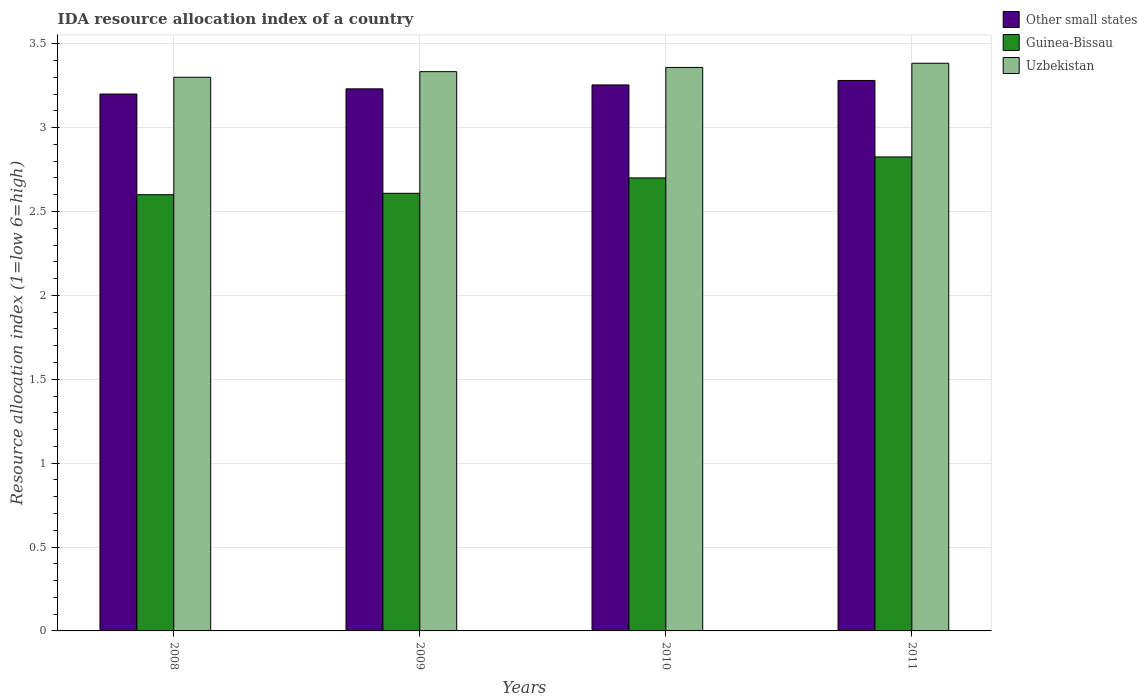Are the number of bars per tick equal to the number of legend labels?
Offer a terse response. Yes. Are the number of bars on each tick of the X-axis equal?
Your response must be concise. Yes. How many bars are there on the 4th tick from the left?
Provide a short and direct response. 3. How many bars are there on the 2nd tick from the right?
Offer a very short reply. 3. What is the label of the 3rd group of bars from the left?
Offer a very short reply. 2010. What is the IDA resource allocation index in Guinea-Bissau in 2010?
Your answer should be compact. 2.7. Across all years, what is the maximum IDA resource allocation index in Other small states?
Your answer should be compact. 3.28. In which year was the IDA resource allocation index in Uzbekistan minimum?
Offer a terse response. 2008. What is the total IDA resource allocation index in Guinea-Bissau in the graph?
Offer a terse response. 10.73. What is the difference between the IDA resource allocation index in Uzbekistan in 2010 and that in 2011?
Ensure brevity in your answer.  -0.03. What is the difference between the IDA resource allocation index in Uzbekistan in 2011 and the IDA resource allocation index in Other small states in 2009?
Make the answer very short. 0.15. What is the average IDA resource allocation index in Guinea-Bissau per year?
Provide a short and direct response. 2.68. In the year 2010, what is the difference between the IDA resource allocation index in Guinea-Bissau and IDA resource allocation index in Uzbekistan?
Provide a succinct answer. -0.66. In how many years, is the IDA resource allocation index in Uzbekistan greater than 0.2?
Keep it short and to the point. 4. What is the ratio of the IDA resource allocation index in Uzbekistan in 2010 to that in 2011?
Offer a terse response. 0.99. Is the IDA resource allocation index in Other small states in 2009 less than that in 2011?
Offer a very short reply. Yes. Is the difference between the IDA resource allocation index in Guinea-Bissau in 2009 and 2011 greater than the difference between the IDA resource allocation index in Uzbekistan in 2009 and 2011?
Your answer should be very brief. No. What is the difference between the highest and the second highest IDA resource allocation index in Other small states?
Ensure brevity in your answer.  0.03. What is the difference between the highest and the lowest IDA resource allocation index in Uzbekistan?
Your answer should be very brief. 0.08. In how many years, is the IDA resource allocation index in Guinea-Bissau greater than the average IDA resource allocation index in Guinea-Bissau taken over all years?
Make the answer very short. 2. Is the sum of the IDA resource allocation index in Guinea-Bissau in 2008 and 2009 greater than the maximum IDA resource allocation index in Other small states across all years?
Provide a short and direct response. Yes. What does the 1st bar from the left in 2011 represents?
Ensure brevity in your answer.  Other small states. What does the 3rd bar from the right in 2008 represents?
Make the answer very short. Other small states. How many bars are there?
Your answer should be compact. 12. How many years are there in the graph?
Your response must be concise. 4. What is the difference between two consecutive major ticks on the Y-axis?
Your answer should be compact. 0.5. Does the graph contain grids?
Offer a very short reply. Yes. How many legend labels are there?
Give a very brief answer. 3. How are the legend labels stacked?
Provide a short and direct response. Vertical. What is the title of the graph?
Offer a terse response. IDA resource allocation index of a country. What is the label or title of the X-axis?
Offer a terse response. Years. What is the label or title of the Y-axis?
Provide a short and direct response. Resource allocation index (1=low 6=high). What is the Resource allocation index (1=low 6=high) of Guinea-Bissau in 2008?
Make the answer very short. 2.6. What is the Resource allocation index (1=low 6=high) of Uzbekistan in 2008?
Your answer should be compact. 3.3. What is the Resource allocation index (1=low 6=high) of Other small states in 2009?
Ensure brevity in your answer.  3.23. What is the Resource allocation index (1=low 6=high) in Guinea-Bissau in 2009?
Your answer should be compact. 2.61. What is the Resource allocation index (1=low 6=high) in Uzbekistan in 2009?
Offer a terse response. 3.33. What is the Resource allocation index (1=low 6=high) in Other small states in 2010?
Your answer should be very brief. 3.25. What is the Resource allocation index (1=low 6=high) in Guinea-Bissau in 2010?
Your response must be concise. 2.7. What is the Resource allocation index (1=low 6=high) in Uzbekistan in 2010?
Keep it short and to the point. 3.36. What is the Resource allocation index (1=low 6=high) of Other small states in 2011?
Provide a succinct answer. 3.28. What is the Resource allocation index (1=low 6=high) in Guinea-Bissau in 2011?
Provide a succinct answer. 2.83. What is the Resource allocation index (1=low 6=high) in Uzbekistan in 2011?
Your answer should be very brief. 3.38. Across all years, what is the maximum Resource allocation index (1=low 6=high) in Other small states?
Offer a very short reply. 3.28. Across all years, what is the maximum Resource allocation index (1=low 6=high) of Guinea-Bissau?
Your answer should be very brief. 2.83. Across all years, what is the maximum Resource allocation index (1=low 6=high) in Uzbekistan?
Your answer should be very brief. 3.38. Across all years, what is the minimum Resource allocation index (1=low 6=high) in Guinea-Bissau?
Offer a very short reply. 2.6. Across all years, what is the minimum Resource allocation index (1=low 6=high) in Uzbekistan?
Provide a succinct answer. 3.3. What is the total Resource allocation index (1=low 6=high) of Other small states in the graph?
Keep it short and to the point. 12.97. What is the total Resource allocation index (1=low 6=high) of Guinea-Bissau in the graph?
Provide a succinct answer. 10.73. What is the total Resource allocation index (1=low 6=high) of Uzbekistan in the graph?
Your response must be concise. 13.38. What is the difference between the Resource allocation index (1=low 6=high) in Other small states in 2008 and that in 2009?
Your response must be concise. -0.03. What is the difference between the Resource allocation index (1=low 6=high) of Guinea-Bissau in 2008 and that in 2009?
Your answer should be compact. -0.01. What is the difference between the Resource allocation index (1=low 6=high) in Uzbekistan in 2008 and that in 2009?
Provide a short and direct response. -0.03. What is the difference between the Resource allocation index (1=low 6=high) in Other small states in 2008 and that in 2010?
Your answer should be compact. -0.05. What is the difference between the Resource allocation index (1=low 6=high) of Uzbekistan in 2008 and that in 2010?
Offer a terse response. -0.06. What is the difference between the Resource allocation index (1=low 6=high) in Other small states in 2008 and that in 2011?
Ensure brevity in your answer.  -0.08. What is the difference between the Resource allocation index (1=low 6=high) of Guinea-Bissau in 2008 and that in 2011?
Your answer should be very brief. -0.23. What is the difference between the Resource allocation index (1=low 6=high) in Uzbekistan in 2008 and that in 2011?
Your answer should be very brief. -0.08. What is the difference between the Resource allocation index (1=low 6=high) of Other small states in 2009 and that in 2010?
Your answer should be very brief. -0.02. What is the difference between the Resource allocation index (1=low 6=high) in Guinea-Bissau in 2009 and that in 2010?
Your answer should be compact. -0.09. What is the difference between the Resource allocation index (1=low 6=high) of Uzbekistan in 2009 and that in 2010?
Offer a terse response. -0.03. What is the difference between the Resource allocation index (1=low 6=high) of Guinea-Bissau in 2009 and that in 2011?
Provide a succinct answer. -0.22. What is the difference between the Resource allocation index (1=low 6=high) of Uzbekistan in 2009 and that in 2011?
Provide a succinct answer. -0.05. What is the difference between the Resource allocation index (1=low 6=high) of Other small states in 2010 and that in 2011?
Offer a very short reply. -0.03. What is the difference between the Resource allocation index (1=low 6=high) in Guinea-Bissau in 2010 and that in 2011?
Give a very brief answer. -0.12. What is the difference between the Resource allocation index (1=low 6=high) of Uzbekistan in 2010 and that in 2011?
Offer a terse response. -0.03. What is the difference between the Resource allocation index (1=low 6=high) of Other small states in 2008 and the Resource allocation index (1=low 6=high) of Guinea-Bissau in 2009?
Ensure brevity in your answer.  0.59. What is the difference between the Resource allocation index (1=low 6=high) in Other small states in 2008 and the Resource allocation index (1=low 6=high) in Uzbekistan in 2009?
Make the answer very short. -0.13. What is the difference between the Resource allocation index (1=low 6=high) of Guinea-Bissau in 2008 and the Resource allocation index (1=low 6=high) of Uzbekistan in 2009?
Make the answer very short. -0.73. What is the difference between the Resource allocation index (1=low 6=high) of Other small states in 2008 and the Resource allocation index (1=low 6=high) of Uzbekistan in 2010?
Give a very brief answer. -0.16. What is the difference between the Resource allocation index (1=low 6=high) of Guinea-Bissau in 2008 and the Resource allocation index (1=low 6=high) of Uzbekistan in 2010?
Give a very brief answer. -0.76. What is the difference between the Resource allocation index (1=low 6=high) in Other small states in 2008 and the Resource allocation index (1=low 6=high) in Guinea-Bissau in 2011?
Your response must be concise. 0.38. What is the difference between the Resource allocation index (1=low 6=high) in Other small states in 2008 and the Resource allocation index (1=low 6=high) in Uzbekistan in 2011?
Give a very brief answer. -0.18. What is the difference between the Resource allocation index (1=low 6=high) in Guinea-Bissau in 2008 and the Resource allocation index (1=low 6=high) in Uzbekistan in 2011?
Your answer should be compact. -0.78. What is the difference between the Resource allocation index (1=low 6=high) in Other small states in 2009 and the Resource allocation index (1=low 6=high) in Guinea-Bissau in 2010?
Make the answer very short. 0.53. What is the difference between the Resource allocation index (1=low 6=high) in Other small states in 2009 and the Resource allocation index (1=low 6=high) in Uzbekistan in 2010?
Make the answer very short. -0.13. What is the difference between the Resource allocation index (1=low 6=high) in Guinea-Bissau in 2009 and the Resource allocation index (1=low 6=high) in Uzbekistan in 2010?
Provide a succinct answer. -0.75. What is the difference between the Resource allocation index (1=low 6=high) in Other small states in 2009 and the Resource allocation index (1=low 6=high) in Guinea-Bissau in 2011?
Offer a terse response. 0.41. What is the difference between the Resource allocation index (1=low 6=high) in Other small states in 2009 and the Resource allocation index (1=low 6=high) in Uzbekistan in 2011?
Give a very brief answer. -0.15. What is the difference between the Resource allocation index (1=low 6=high) of Guinea-Bissau in 2009 and the Resource allocation index (1=low 6=high) of Uzbekistan in 2011?
Provide a short and direct response. -0.78. What is the difference between the Resource allocation index (1=low 6=high) in Other small states in 2010 and the Resource allocation index (1=low 6=high) in Guinea-Bissau in 2011?
Provide a succinct answer. 0.43. What is the difference between the Resource allocation index (1=low 6=high) in Other small states in 2010 and the Resource allocation index (1=low 6=high) in Uzbekistan in 2011?
Provide a succinct answer. -0.13. What is the difference between the Resource allocation index (1=low 6=high) of Guinea-Bissau in 2010 and the Resource allocation index (1=low 6=high) of Uzbekistan in 2011?
Offer a terse response. -0.68. What is the average Resource allocation index (1=low 6=high) of Other small states per year?
Give a very brief answer. 3.24. What is the average Resource allocation index (1=low 6=high) in Guinea-Bissau per year?
Offer a terse response. 2.68. What is the average Resource allocation index (1=low 6=high) in Uzbekistan per year?
Your response must be concise. 3.34. In the year 2008, what is the difference between the Resource allocation index (1=low 6=high) of Other small states and Resource allocation index (1=low 6=high) of Uzbekistan?
Give a very brief answer. -0.1. In the year 2009, what is the difference between the Resource allocation index (1=low 6=high) in Other small states and Resource allocation index (1=low 6=high) in Guinea-Bissau?
Keep it short and to the point. 0.62. In the year 2009, what is the difference between the Resource allocation index (1=low 6=high) in Other small states and Resource allocation index (1=low 6=high) in Uzbekistan?
Provide a succinct answer. -0.1. In the year 2009, what is the difference between the Resource allocation index (1=low 6=high) in Guinea-Bissau and Resource allocation index (1=low 6=high) in Uzbekistan?
Offer a terse response. -0.72. In the year 2010, what is the difference between the Resource allocation index (1=low 6=high) in Other small states and Resource allocation index (1=low 6=high) in Guinea-Bissau?
Your answer should be very brief. 0.55. In the year 2010, what is the difference between the Resource allocation index (1=low 6=high) of Other small states and Resource allocation index (1=low 6=high) of Uzbekistan?
Make the answer very short. -0.1. In the year 2010, what is the difference between the Resource allocation index (1=low 6=high) of Guinea-Bissau and Resource allocation index (1=low 6=high) of Uzbekistan?
Provide a succinct answer. -0.66. In the year 2011, what is the difference between the Resource allocation index (1=low 6=high) in Other small states and Resource allocation index (1=low 6=high) in Guinea-Bissau?
Your response must be concise. 0.46. In the year 2011, what is the difference between the Resource allocation index (1=low 6=high) of Other small states and Resource allocation index (1=low 6=high) of Uzbekistan?
Your response must be concise. -0.1. In the year 2011, what is the difference between the Resource allocation index (1=low 6=high) in Guinea-Bissau and Resource allocation index (1=low 6=high) in Uzbekistan?
Ensure brevity in your answer.  -0.56. What is the ratio of the Resource allocation index (1=low 6=high) in Guinea-Bissau in 2008 to that in 2009?
Your response must be concise. 1. What is the ratio of the Resource allocation index (1=low 6=high) in Uzbekistan in 2008 to that in 2009?
Your answer should be very brief. 0.99. What is the ratio of the Resource allocation index (1=low 6=high) of Other small states in 2008 to that in 2010?
Your answer should be compact. 0.98. What is the ratio of the Resource allocation index (1=low 6=high) of Guinea-Bissau in 2008 to that in 2010?
Provide a short and direct response. 0.96. What is the ratio of the Resource allocation index (1=low 6=high) in Uzbekistan in 2008 to that in 2010?
Offer a very short reply. 0.98. What is the ratio of the Resource allocation index (1=low 6=high) of Other small states in 2008 to that in 2011?
Keep it short and to the point. 0.98. What is the ratio of the Resource allocation index (1=low 6=high) of Guinea-Bissau in 2008 to that in 2011?
Provide a short and direct response. 0.92. What is the ratio of the Resource allocation index (1=low 6=high) in Uzbekistan in 2008 to that in 2011?
Your answer should be very brief. 0.98. What is the ratio of the Resource allocation index (1=low 6=high) in Other small states in 2009 to that in 2011?
Keep it short and to the point. 0.98. What is the ratio of the Resource allocation index (1=low 6=high) of Guinea-Bissau in 2009 to that in 2011?
Your response must be concise. 0.92. What is the ratio of the Resource allocation index (1=low 6=high) in Uzbekistan in 2009 to that in 2011?
Offer a terse response. 0.99. What is the ratio of the Resource allocation index (1=low 6=high) in Guinea-Bissau in 2010 to that in 2011?
Offer a terse response. 0.96. What is the ratio of the Resource allocation index (1=low 6=high) in Uzbekistan in 2010 to that in 2011?
Your answer should be compact. 0.99. What is the difference between the highest and the second highest Resource allocation index (1=low 6=high) of Other small states?
Your answer should be compact. 0.03. What is the difference between the highest and the second highest Resource allocation index (1=low 6=high) in Guinea-Bissau?
Make the answer very short. 0.12. What is the difference between the highest and the second highest Resource allocation index (1=low 6=high) in Uzbekistan?
Offer a terse response. 0.03. What is the difference between the highest and the lowest Resource allocation index (1=low 6=high) in Other small states?
Give a very brief answer. 0.08. What is the difference between the highest and the lowest Resource allocation index (1=low 6=high) of Guinea-Bissau?
Provide a succinct answer. 0.23. What is the difference between the highest and the lowest Resource allocation index (1=low 6=high) of Uzbekistan?
Your response must be concise. 0.08. 